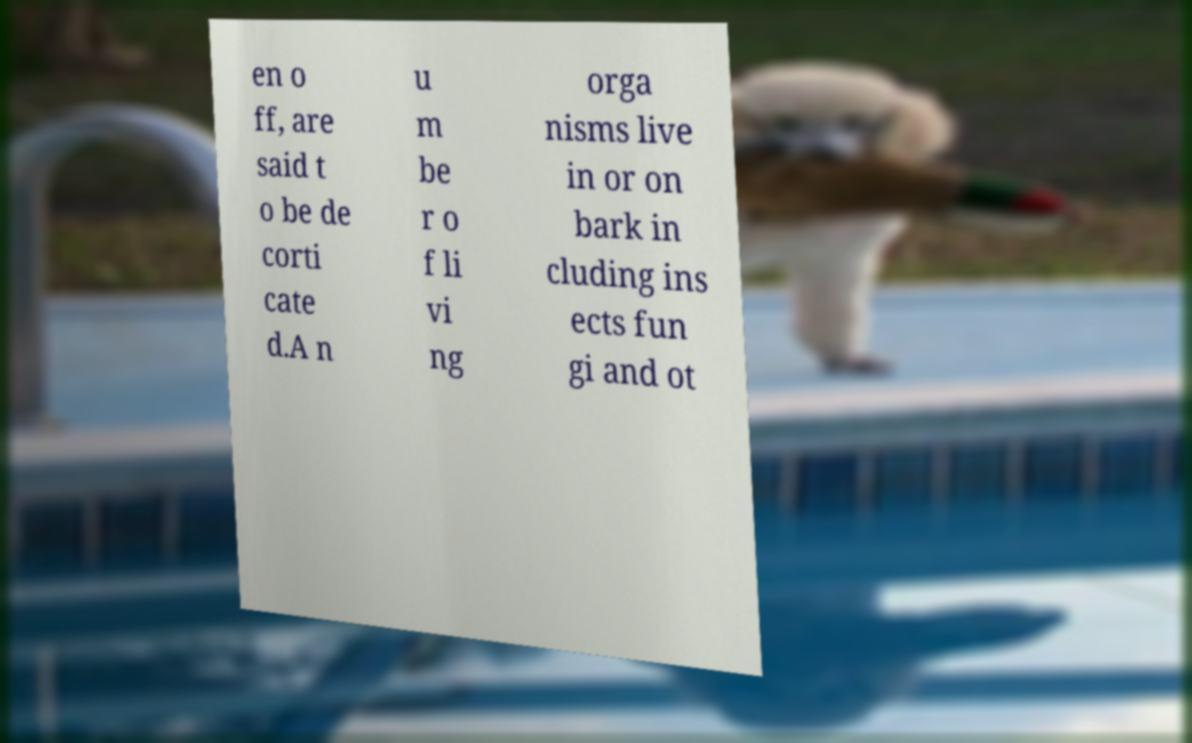Can you accurately transcribe the text from the provided image for me? en o ff, are said t o be de corti cate d.A n u m be r o f li vi ng orga nisms live in or on bark in cluding ins ects fun gi and ot 